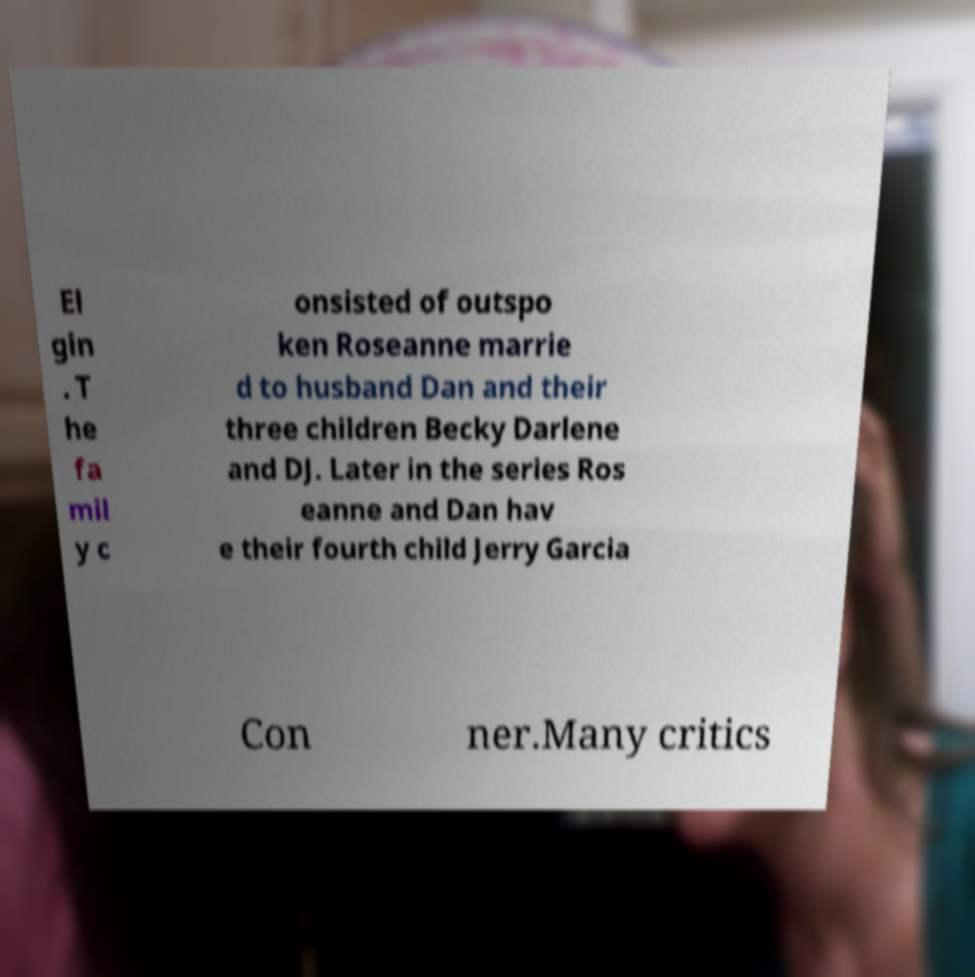Please identify and transcribe the text found in this image. El gin . T he fa mil y c onsisted of outspo ken Roseanne marrie d to husband Dan and their three children Becky Darlene and DJ. Later in the series Ros eanne and Dan hav e their fourth child Jerry Garcia Con ner.Many critics 